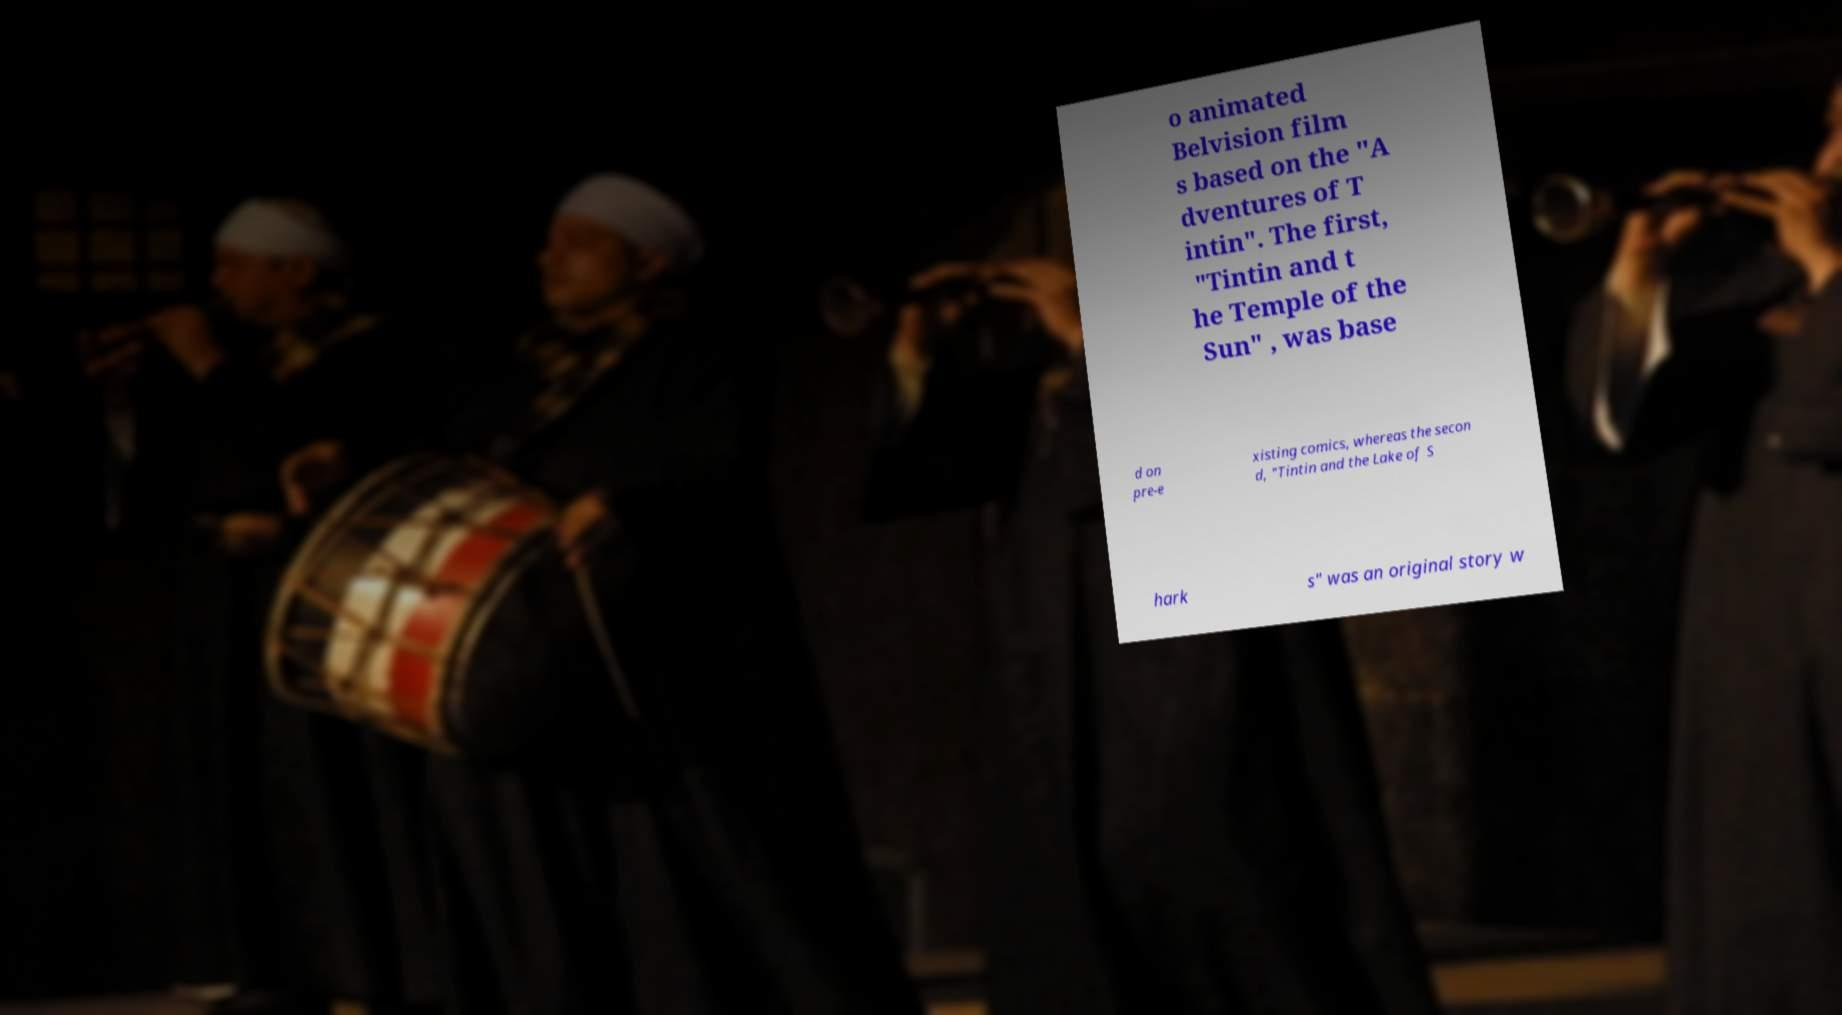Can you accurately transcribe the text from the provided image for me? o animated Belvision film s based on the "A dventures of T intin". The first, "Tintin and t he Temple of the Sun" , was base d on pre-e xisting comics, whereas the secon d, "Tintin and the Lake of S hark s" was an original story w 